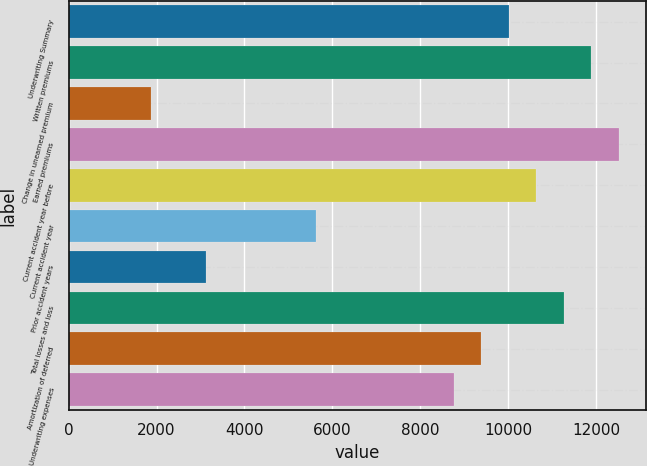Convert chart. <chart><loc_0><loc_0><loc_500><loc_500><bar_chart><fcel>Underwriting Summary<fcel>Written premiums<fcel>Change in unearned premium<fcel>Earned premiums<fcel>Current accident year before<fcel>Current accident year<fcel>Prior accident years<fcel>Total losses and loss<fcel>Amortization of deferred<fcel>Underwriting expenses<nl><fcel>10011.4<fcel>11887.6<fcel>1881.2<fcel>12513<fcel>10636.8<fcel>5633.6<fcel>3132<fcel>11262.2<fcel>9386<fcel>8760.6<nl></chart> 